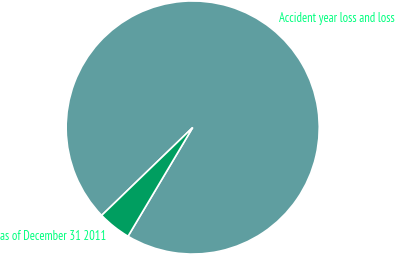Convert chart. <chart><loc_0><loc_0><loc_500><loc_500><pie_chart><fcel>Accident year loss and loss<fcel>as of December 31 2011<nl><fcel>95.76%<fcel>4.24%<nl></chart> 